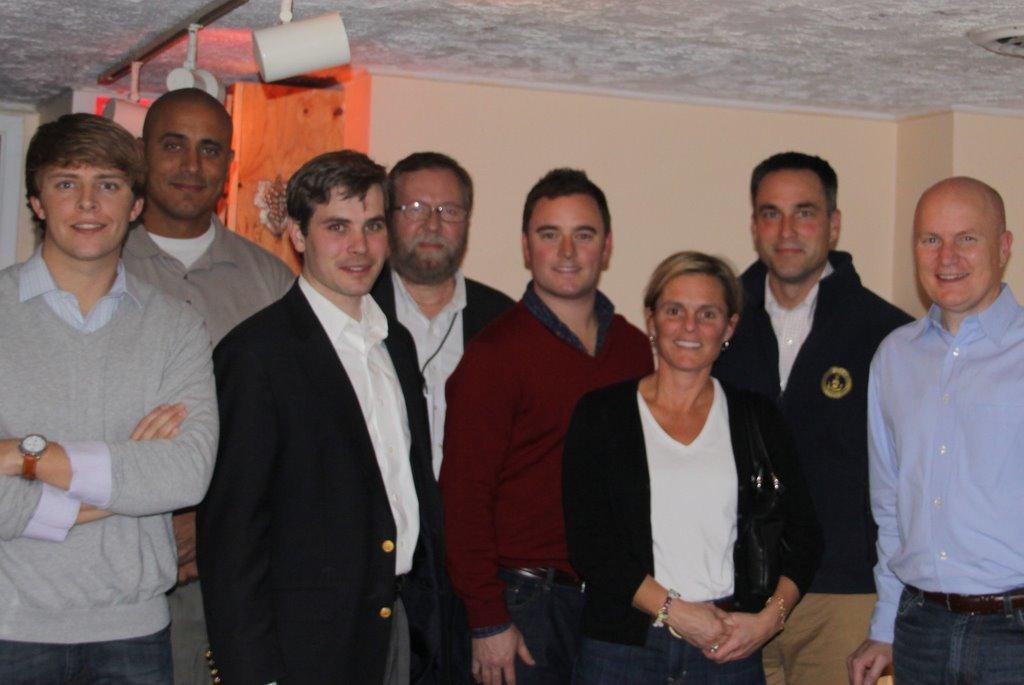Could you give a brief overview of what you see in this image? In this image we can see some people standing. On the backside we can see some lights, wall and a roof. 